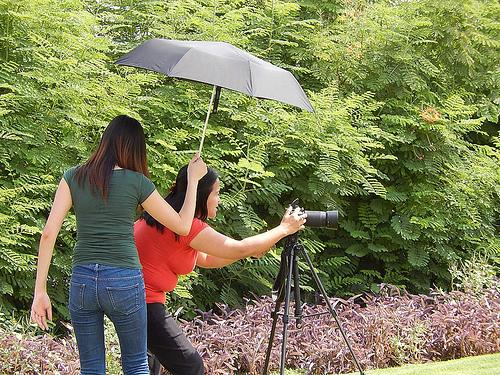Consider this image for a product advertisement task, which items could be advertised and in what context? The camera and tripod could be advertised for photography enthusiasts, while the black umbrella could be promoted for outdoor use in various weather conditions. Describe any distinct attire or accessories worn by one or both women. One woman is wearing a red shirt and the other is wearing a green shirt; they are holding a black umbrella. Where is the camera positioned and what is it resting on? The camera is positioned at the height of the women's faces, resting on a black tripod stand in the grass. Identify the items in this photograph related to photography and their respective colors. A long-lens camera on a black tripod and two women using it, one wearing a red shirt and the other wearing a green shirt. Could you provide an explanation about the setting of this image? The image is set outdoors, with trees and bushes in the background, tripod and camera on the grass, and two women interacting with the camera. What equipment can be seen in the image related to the VQA task? There is a long-lens camera on a black tripod stand, and a black umbrella being held by one of the women. Regarding the visual entailment task, what elements suggest that the women are actively engaged in photography? The positions of the women in front of the camera, the presence of a tripod supporting a long-lens camera, and their focused expressions suggest they are actively engaged in the photography process. What is the main focus of the image? Two women using a camera and holding an umbrella, with trees and foliage in the background. In a referential expression grounding task, describe the location of the camera and umbrella present in the image. The camera is mounted on a black tripod stand in the grass, while one woman is holding a black umbrella near the camera. What is the color of the umbrella, and who appears to be holding it? The umbrella is black and a woman wearing a green shirt appears to be holding it. 